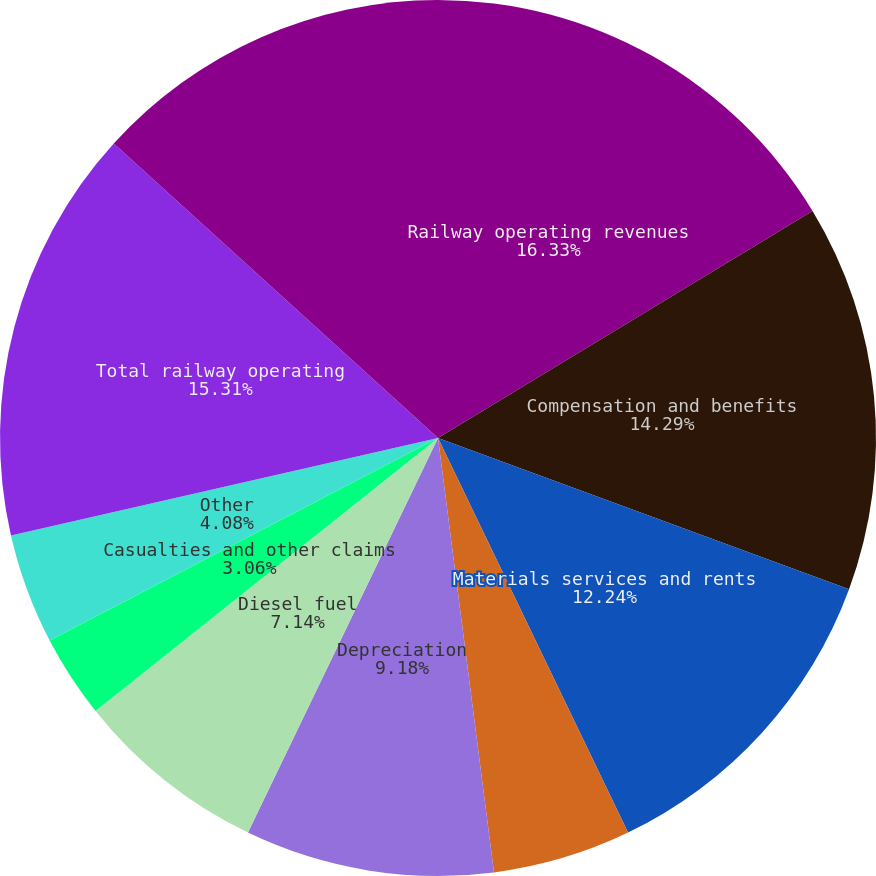Convert chart. <chart><loc_0><loc_0><loc_500><loc_500><pie_chart><fcel>Railway operating revenues<fcel>Compensation and benefits<fcel>Materials services and rents<fcel>Conrail rents and services<fcel>Depreciation<fcel>Diesel fuel<fcel>Casualties and other claims<fcel>Other<fcel>Total railway operating<fcel>Income from railway operations<nl><fcel>16.32%<fcel>14.28%<fcel>12.24%<fcel>5.1%<fcel>9.18%<fcel>7.14%<fcel>3.06%<fcel>4.08%<fcel>15.3%<fcel>13.26%<nl></chart> 